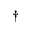<formula> <loc_0><loc_0><loc_500><loc_500>^ { \dagger }</formula> 